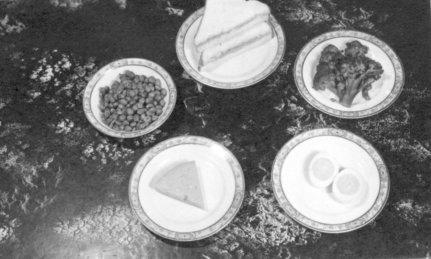Is this a colored picture?
Short answer required. No. What's on the plates?
Concise answer only. Food. How many dishes are shown?
Keep it brief. 5. 